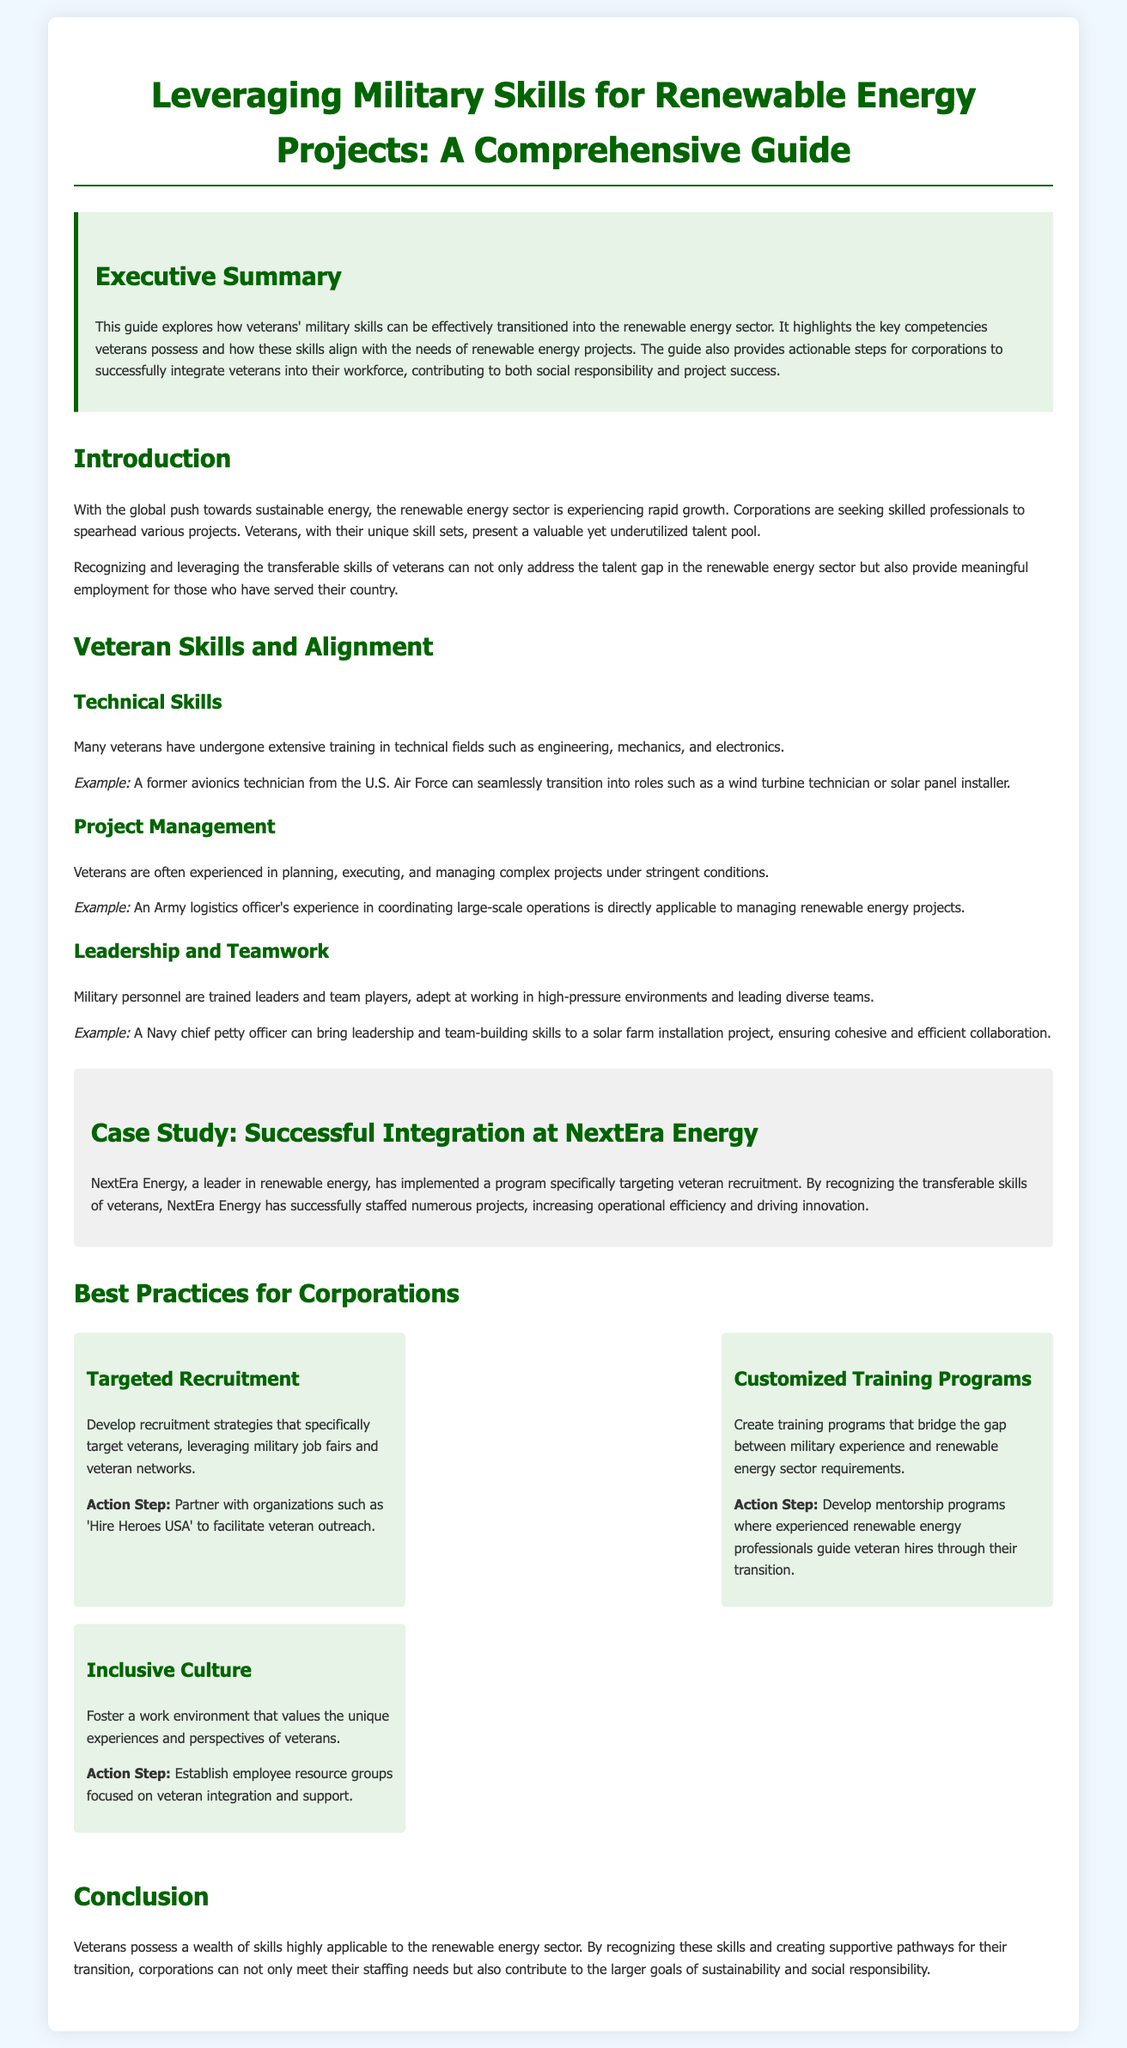What is the main focus of the guide? The guide focuses on how veterans' military skills can be effectively transitioned into the renewable energy sector.
Answer: transitioning military skills Which corporation is highlighted in the case study? The case study details the integration of veterans at a specific corporation known for renewable energy.
Answer: NextEra Energy What type of skills do veterans have that align with renewable energy projects? The document lists various skills, one of which is project management among others that veterans possess.
Answer: project management What is one action step for targeted recruitment? The document suggests a partnership with a specific organization to facilitate veteran outreach in recruitment strategies.
Answer: 'Hire Heroes USA' What is one example of a technical skill veterans may possess? The guide provides an example of a specific military role that aligns with a position in renewable energy.
Answer: avionics technician How do veterans contribute to project management in renewable energy? Veterans have experience in coordinating and managing operations, which is directly related to renewable energy project management.
Answer: coordinating large-scale operations What type of training programs does the guide recommend? It suggests creating training programs that address the gap between military and renewable energy sector requirements.
Answer: customized training programs What aspect of corporate culture does the guide emphasize for veteran integration? The guide points out the importance of a work environment that values particular experiences and perspectives.
Answer: inclusive culture 